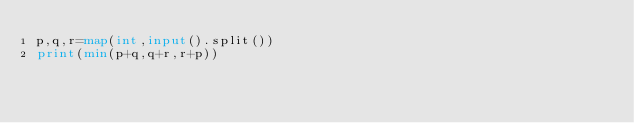Convert code to text. <code><loc_0><loc_0><loc_500><loc_500><_Python_>p,q,r=map(int,input().split())
print(min(p+q,q+r,r+p))</code> 